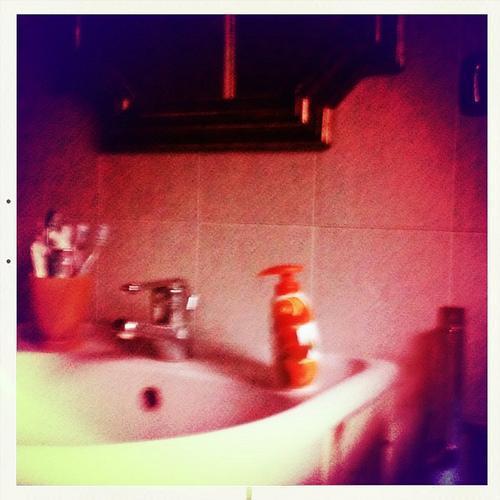How many sinks are in this picture?
Give a very brief answer. 1. 